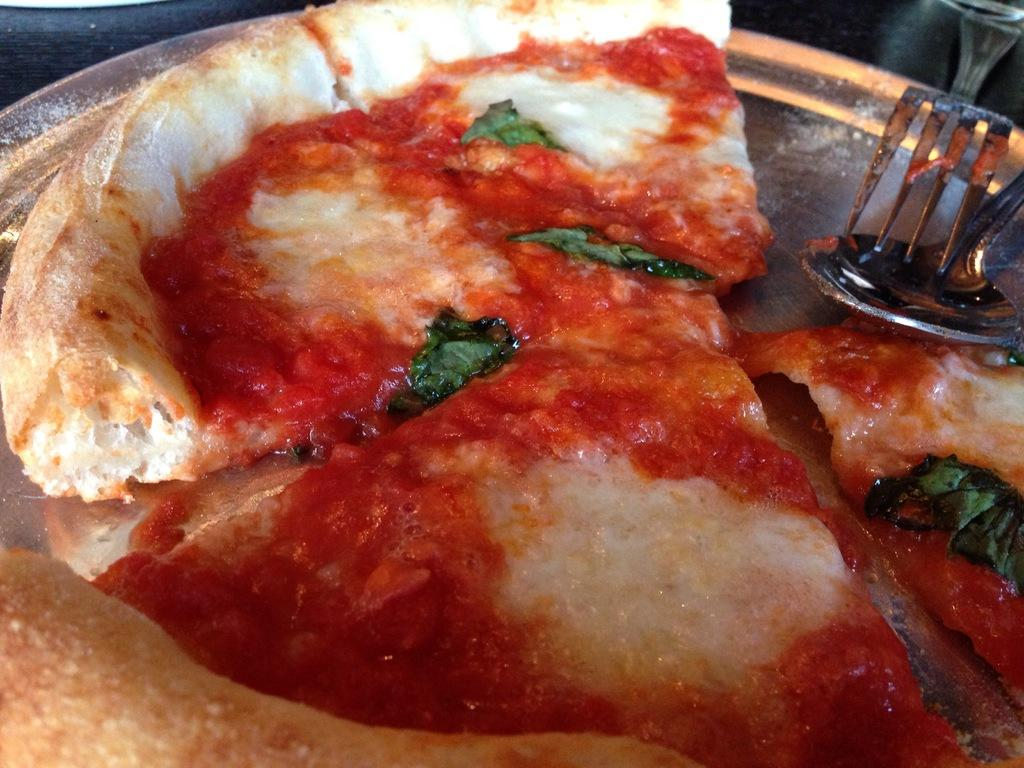What is on the plate that is visible in the image? There is a plate with food in the image. What utensils are on the plate? There is a spoon and a fork on the plate. Where is the plate and utensils located? The plate and utensils are on a table. How many pears are on the plate in the image? There are no pears present on the plate in the image. 